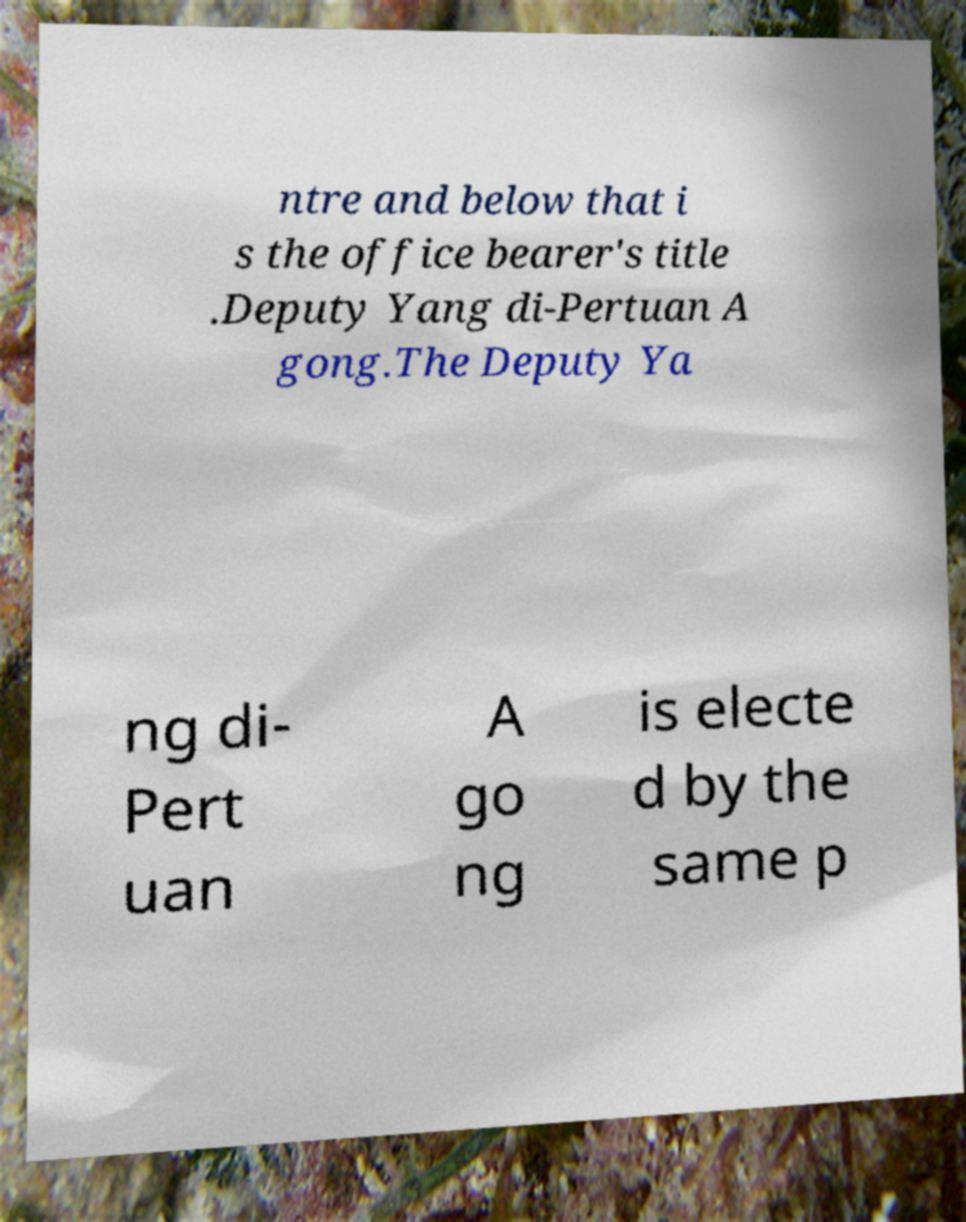For documentation purposes, I need the text within this image transcribed. Could you provide that? ntre and below that i s the office bearer's title .Deputy Yang di-Pertuan A gong.The Deputy Ya ng di- Pert uan A go ng is electe d by the same p 